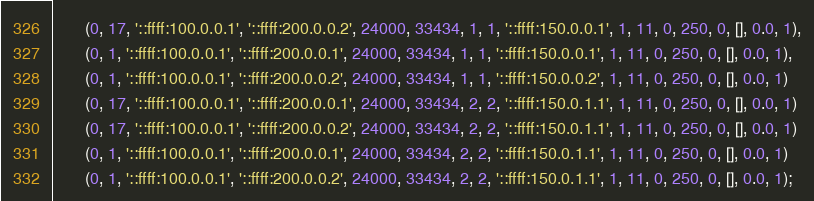<code> <loc_0><loc_0><loc_500><loc_500><_SQL_>       (0, 17, '::ffff:100.0.0.1', '::ffff:200.0.0.2', 24000, 33434, 1, 1, '::ffff:150.0.0.1', 1, 11, 0, 250, 0, [], 0.0, 1),
       (0, 1, '::ffff:100.0.0.1', '::ffff:200.0.0.1', 24000, 33434, 1, 1, '::ffff:150.0.0.1', 1, 11, 0, 250, 0, [], 0.0, 1),
       (0, 1, '::ffff:100.0.0.1', '::ffff:200.0.0.2', 24000, 33434, 1, 1, '::ffff:150.0.0.2', 1, 11, 0, 250, 0, [], 0.0, 1)
       (0, 17, '::ffff:100.0.0.1', '::ffff:200.0.0.1', 24000, 33434, 2, 2, '::ffff:150.0.1.1', 1, 11, 0, 250, 0, [], 0.0, 1)
       (0, 17, '::ffff:100.0.0.1', '::ffff:200.0.0.2', 24000, 33434, 2, 2, '::ffff:150.0.1.1', 1, 11, 0, 250, 0, [], 0.0, 1)
       (0, 1, '::ffff:100.0.0.1', '::ffff:200.0.0.1', 24000, 33434, 2, 2, '::ffff:150.0.1.1', 1, 11, 0, 250, 0, [], 0.0, 1)
       (0, 1, '::ffff:100.0.0.1', '::ffff:200.0.0.2', 24000, 33434, 2, 2, '::ffff:150.0.1.1', 1, 11, 0, 250, 0, [], 0.0, 1);
</code> 